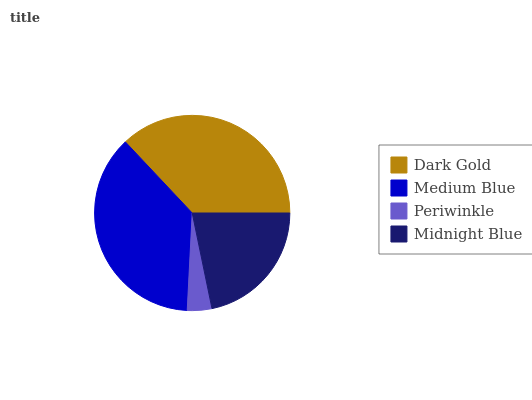Is Periwinkle the minimum?
Answer yes or no. Yes. Is Medium Blue the maximum?
Answer yes or no. Yes. Is Medium Blue the minimum?
Answer yes or no. No. Is Periwinkle the maximum?
Answer yes or no. No. Is Medium Blue greater than Periwinkle?
Answer yes or no. Yes. Is Periwinkle less than Medium Blue?
Answer yes or no. Yes. Is Periwinkle greater than Medium Blue?
Answer yes or no. No. Is Medium Blue less than Periwinkle?
Answer yes or no. No. Is Dark Gold the high median?
Answer yes or no. Yes. Is Midnight Blue the low median?
Answer yes or no. Yes. Is Periwinkle the high median?
Answer yes or no. No. Is Dark Gold the low median?
Answer yes or no. No. 